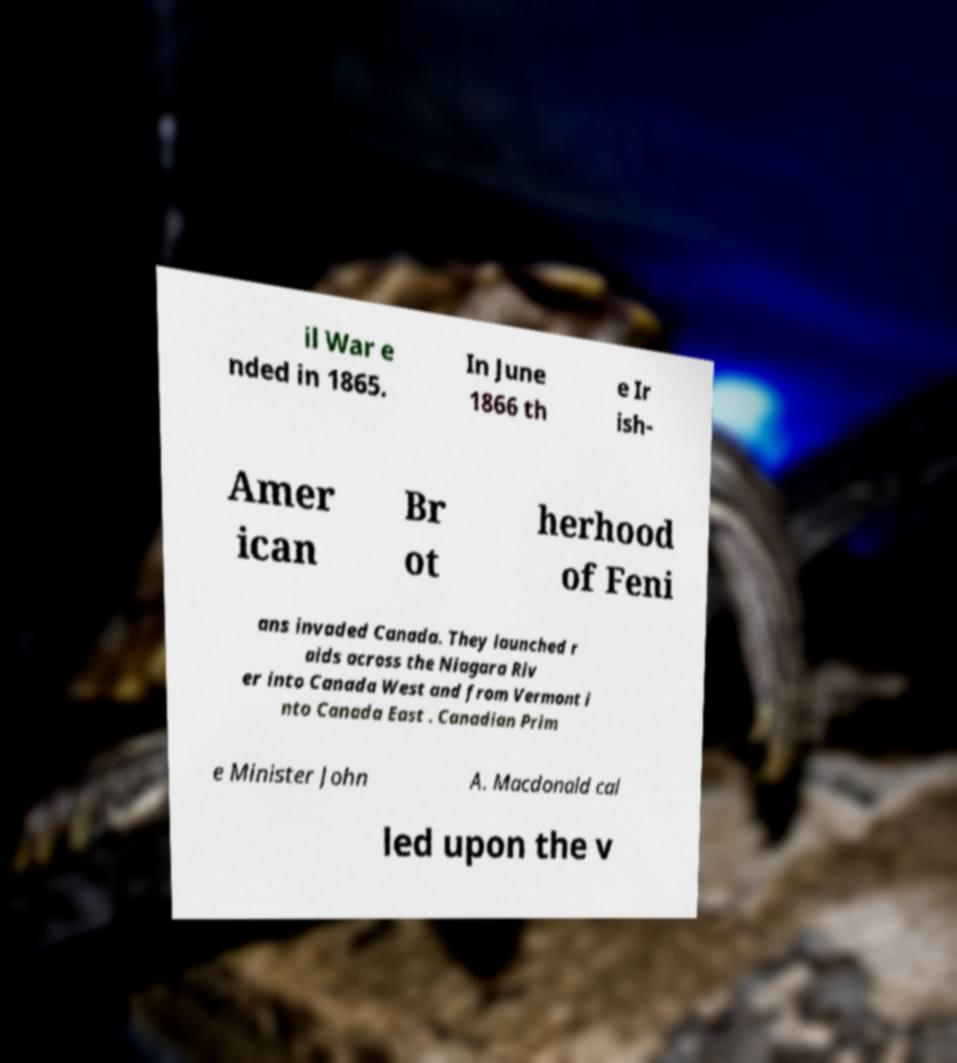There's text embedded in this image that I need extracted. Can you transcribe it verbatim? il War e nded in 1865. In June 1866 th e Ir ish- Amer ican Br ot herhood of Feni ans invaded Canada. They launched r aids across the Niagara Riv er into Canada West and from Vermont i nto Canada East . Canadian Prim e Minister John A. Macdonald cal led upon the v 